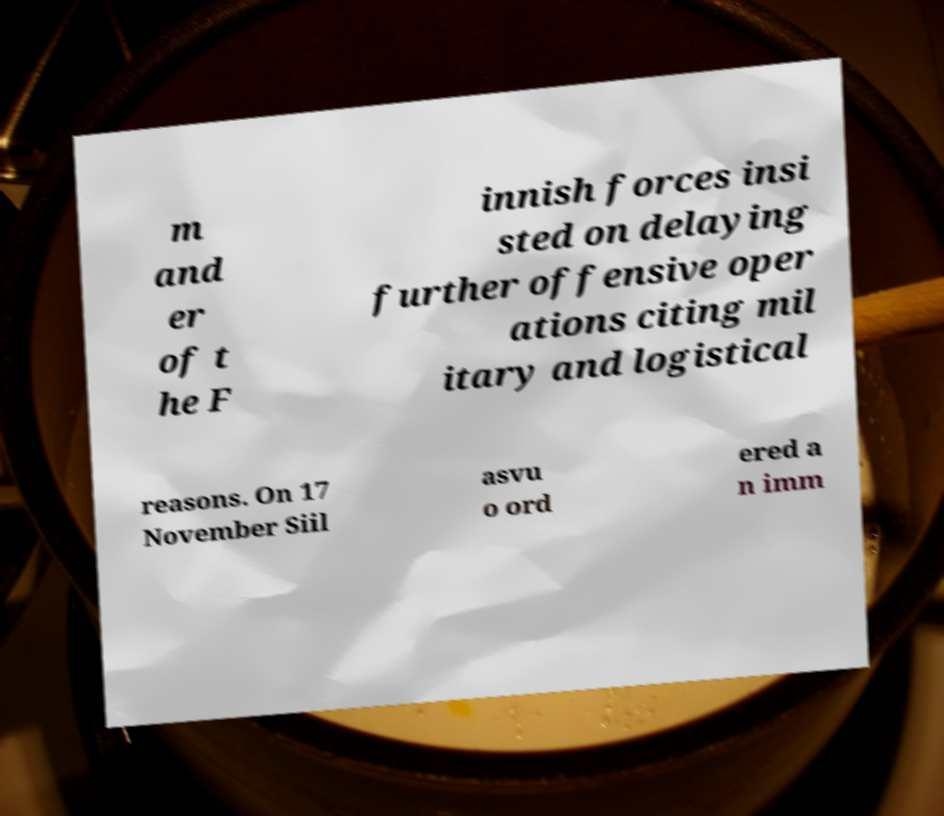Can you accurately transcribe the text from the provided image for me? m and er of t he F innish forces insi sted on delaying further offensive oper ations citing mil itary and logistical reasons. On 17 November Siil asvu o ord ered a n imm 